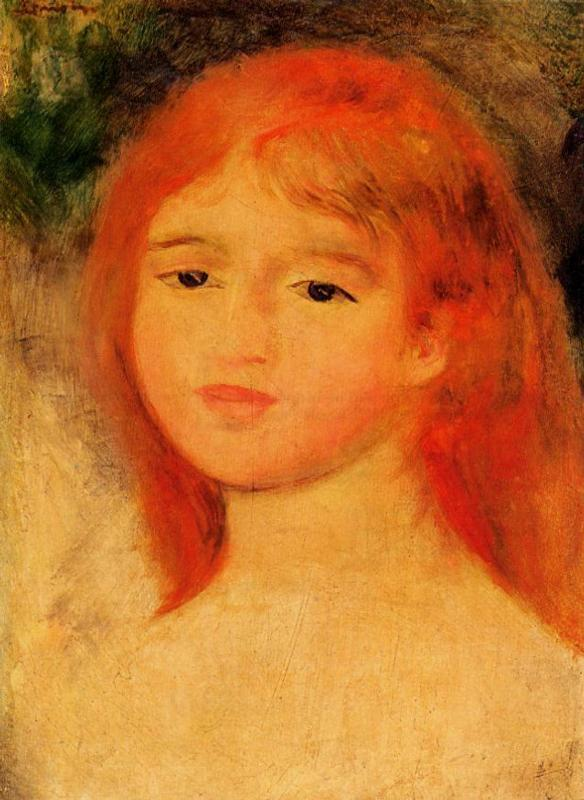What do you see happening in this image? The painting portrays a young girl with vivid red hair, capturing a delicate moment of her simplicity and beauty. Portrayed in the impressionist style, her striking orange-red hair is set against a soft backdrop of greens, yellows, and a hint of blue, enhancing the sense of depth and serenity. Her gentle, tilted pose and pale complexion marked with a rosy blush bring a lifelike warmth and contemplativeness to the scene. This artwork not only highlights the technical prowess of loose brushstrokes and color play typical of impressionism but also subtly reflects the innocence and introspective mood of the subject, inviting viewers into a quiet moment in her world. 